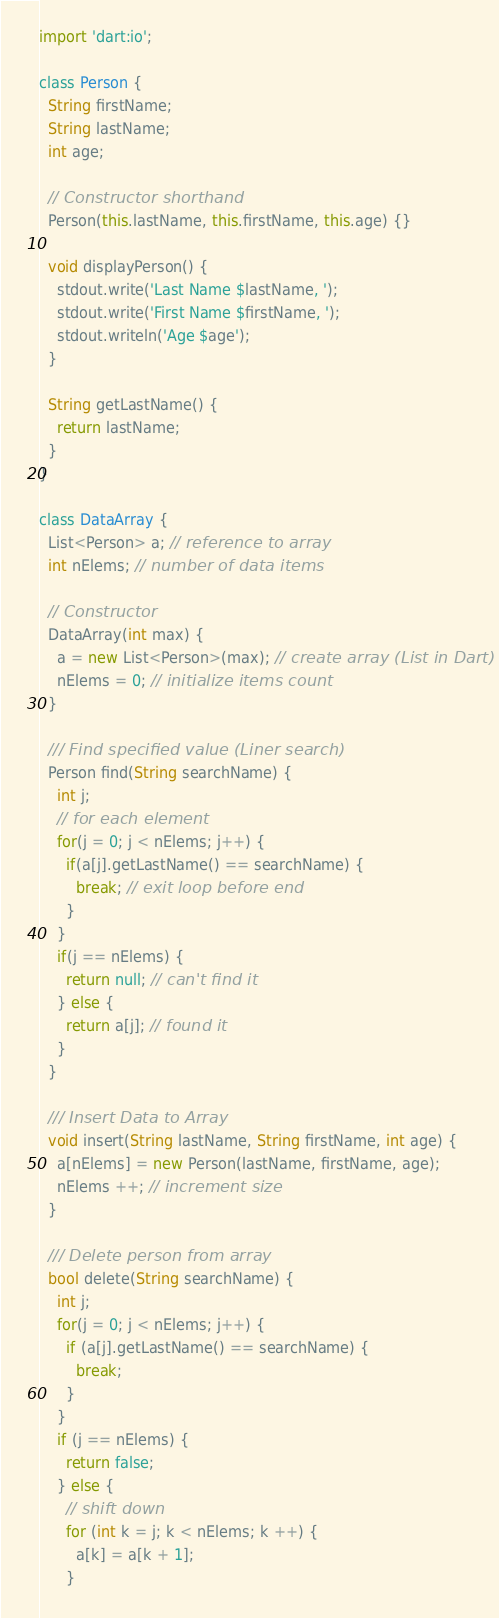<code> <loc_0><loc_0><loc_500><loc_500><_Dart_>import 'dart:io';

class Person {
  String firstName;
  String lastName;
  int age;

  // Constructor shorthand
  Person(this.lastName, this.firstName, this.age) {}

  void displayPerson() {
    stdout.write('Last Name $lastName, ');
    stdout.write('First Name $firstName, ');
    stdout.writeln('Age $age');
  }

  String getLastName() {
    return lastName;
  }
}

class DataArray {
  List<Person> a; // reference to array
  int nElems; // number of data items

  // Constructor
  DataArray(int max) {
    a = new List<Person>(max); // create array (List in Dart)
    nElems = 0; // initialize items count
  }

  /// Find specified value (Liner search)
  Person find(String searchName) {
    int j;
    // for each element
    for(j = 0; j < nElems; j++) {
      if(a[j].getLastName() == searchName) {
        break; // exit loop before end
      }
    }
    if(j == nElems) {
      return null; // can't find it
    } else {
      return a[j]; // found it
    }
  }

  /// Insert Data to Array
  void insert(String lastName, String firstName, int age) {
    a[nElems] = new Person(lastName, firstName, age);
    nElems ++; // increment size
  }

  /// Delete person from array
  bool delete(String searchName) {
    int j;
    for(j = 0; j < nElems; j++) {
      if (a[j].getLastName() == searchName) {
        break;
      }
    }
    if (j == nElems) {
      return false;
    } else {
      // shift down
      for (int k = j; k < nElems; k ++) {
        a[k] = a[k + 1];
      }</code> 